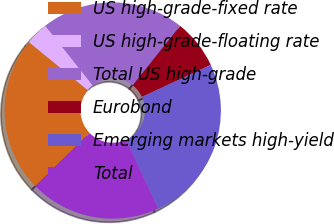Convert chart. <chart><loc_0><loc_0><loc_500><loc_500><pie_chart><fcel>US high-grade-fixed rate<fcel>US high-grade-floating rate<fcel>Total US high-grade<fcel>Eurobond<fcel>Emerging markets high-yield<fcel>Total<nl><fcel>23.22%<fcel>3.42%<fcel>21.41%<fcel>7.34%<fcel>25.03%<fcel>19.6%<nl></chart> 